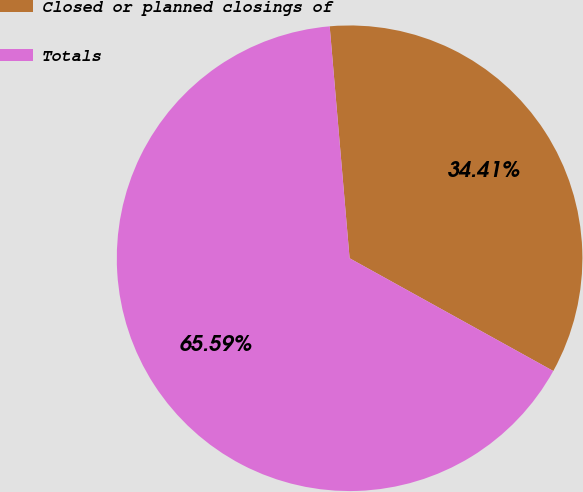Convert chart. <chart><loc_0><loc_0><loc_500><loc_500><pie_chart><fcel>Closed or planned closings of<fcel>Totals<nl><fcel>34.41%<fcel>65.59%<nl></chart> 